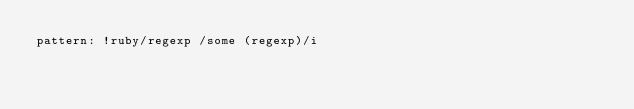Convert code to text. <code><loc_0><loc_0><loc_500><loc_500><_YAML_>pattern: !ruby/regexp /some (regexp)/i
</code> 